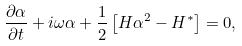<formula> <loc_0><loc_0><loc_500><loc_500>\frac { \partial \alpha } { \partial t } + i \omega \alpha + \frac { 1 } { 2 } \left [ H \alpha ^ { 2 } - H ^ { * } \right ] = 0 ,</formula> 